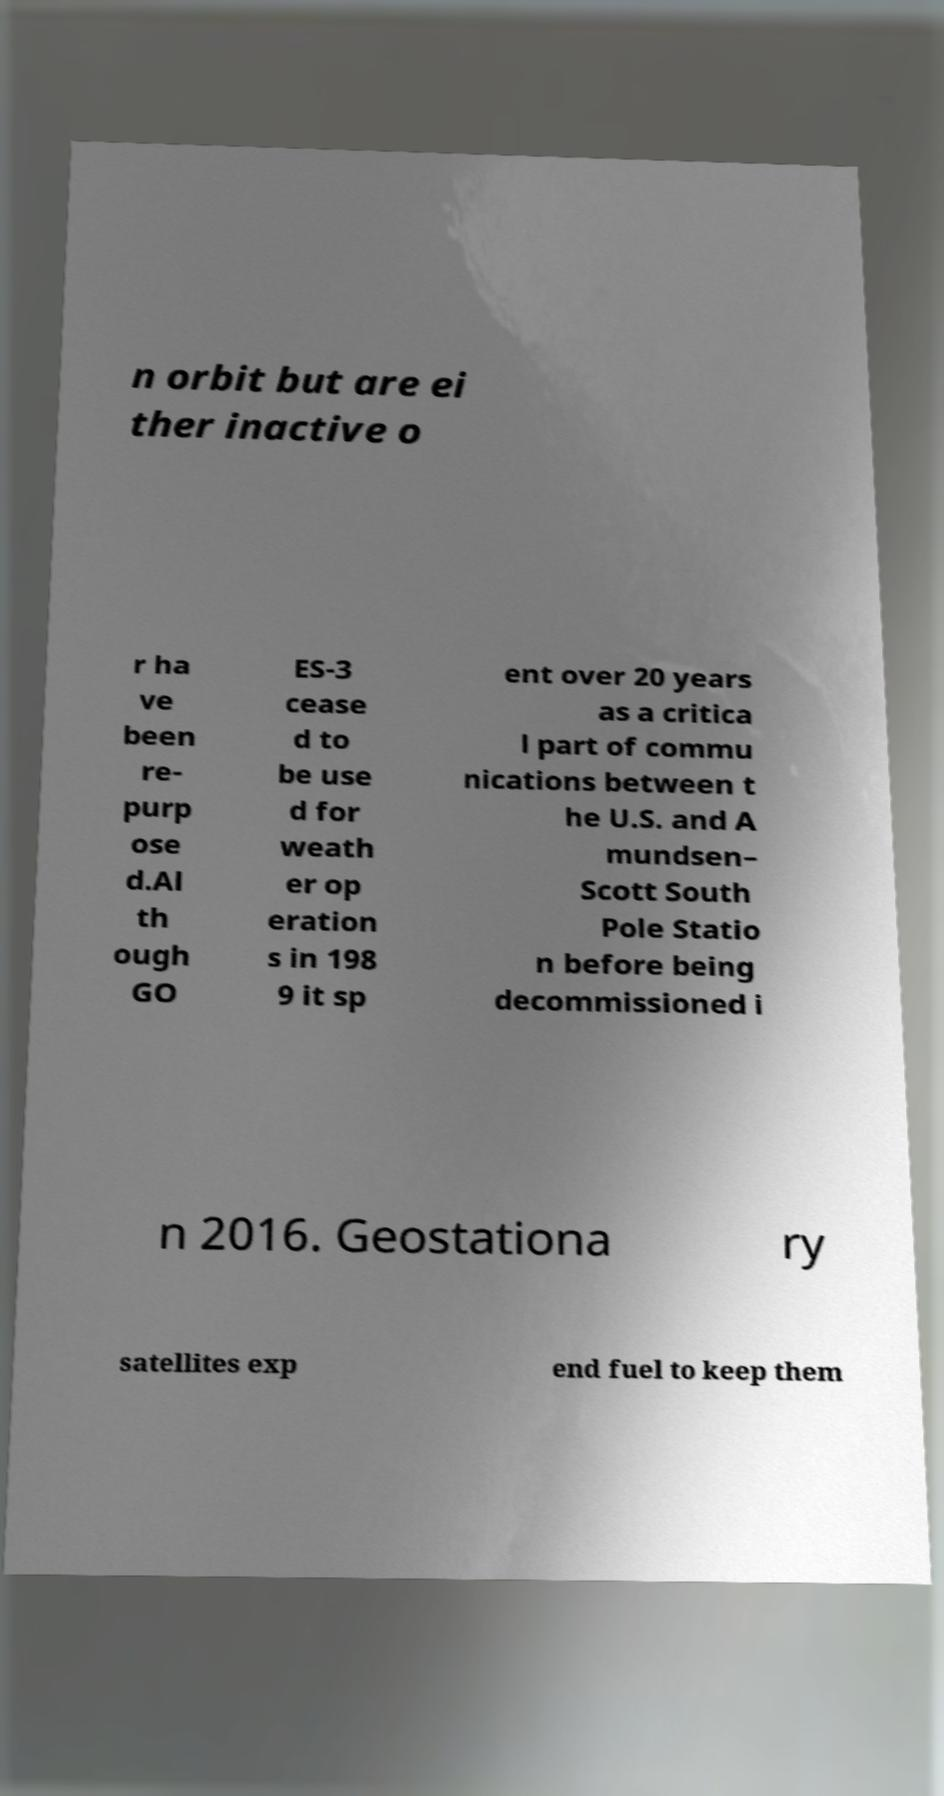Can you read and provide the text displayed in the image?This photo seems to have some interesting text. Can you extract and type it out for me? n orbit but are ei ther inactive o r ha ve been re- purp ose d.Al th ough GO ES-3 cease d to be use d for weath er op eration s in 198 9 it sp ent over 20 years as a critica l part of commu nications between t he U.S. and A mundsen– Scott South Pole Statio n before being decommissioned i n 2016. Geostationa ry satellites exp end fuel to keep them 